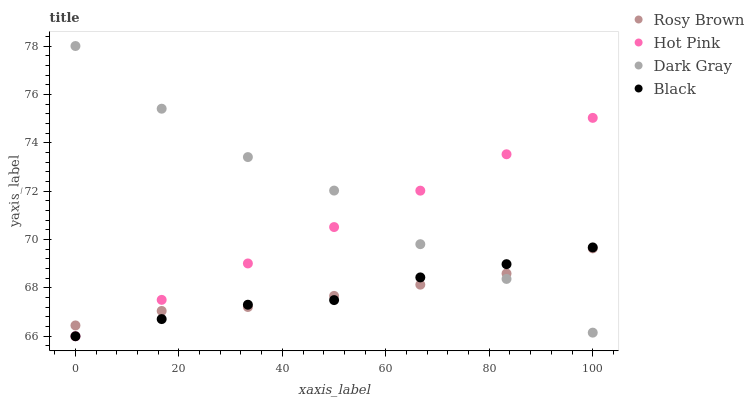Does Rosy Brown have the minimum area under the curve?
Answer yes or no. Yes. Does Dark Gray have the maximum area under the curve?
Answer yes or no. Yes. Does Black have the minimum area under the curve?
Answer yes or no. No. Does Black have the maximum area under the curve?
Answer yes or no. No. Is Hot Pink the smoothest?
Answer yes or no. Yes. Is Dark Gray the roughest?
Answer yes or no. Yes. Is Rosy Brown the smoothest?
Answer yes or no. No. Is Rosy Brown the roughest?
Answer yes or no. No. Does Black have the lowest value?
Answer yes or no. Yes. Does Rosy Brown have the lowest value?
Answer yes or no. No. Does Dark Gray have the highest value?
Answer yes or no. Yes. Does Black have the highest value?
Answer yes or no. No. Does Black intersect Rosy Brown?
Answer yes or no. Yes. Is Black less than Rosy Brown?
Answer yes or no. No. Is Black greater than Rosy Brown?
Answer yes or no. No. 